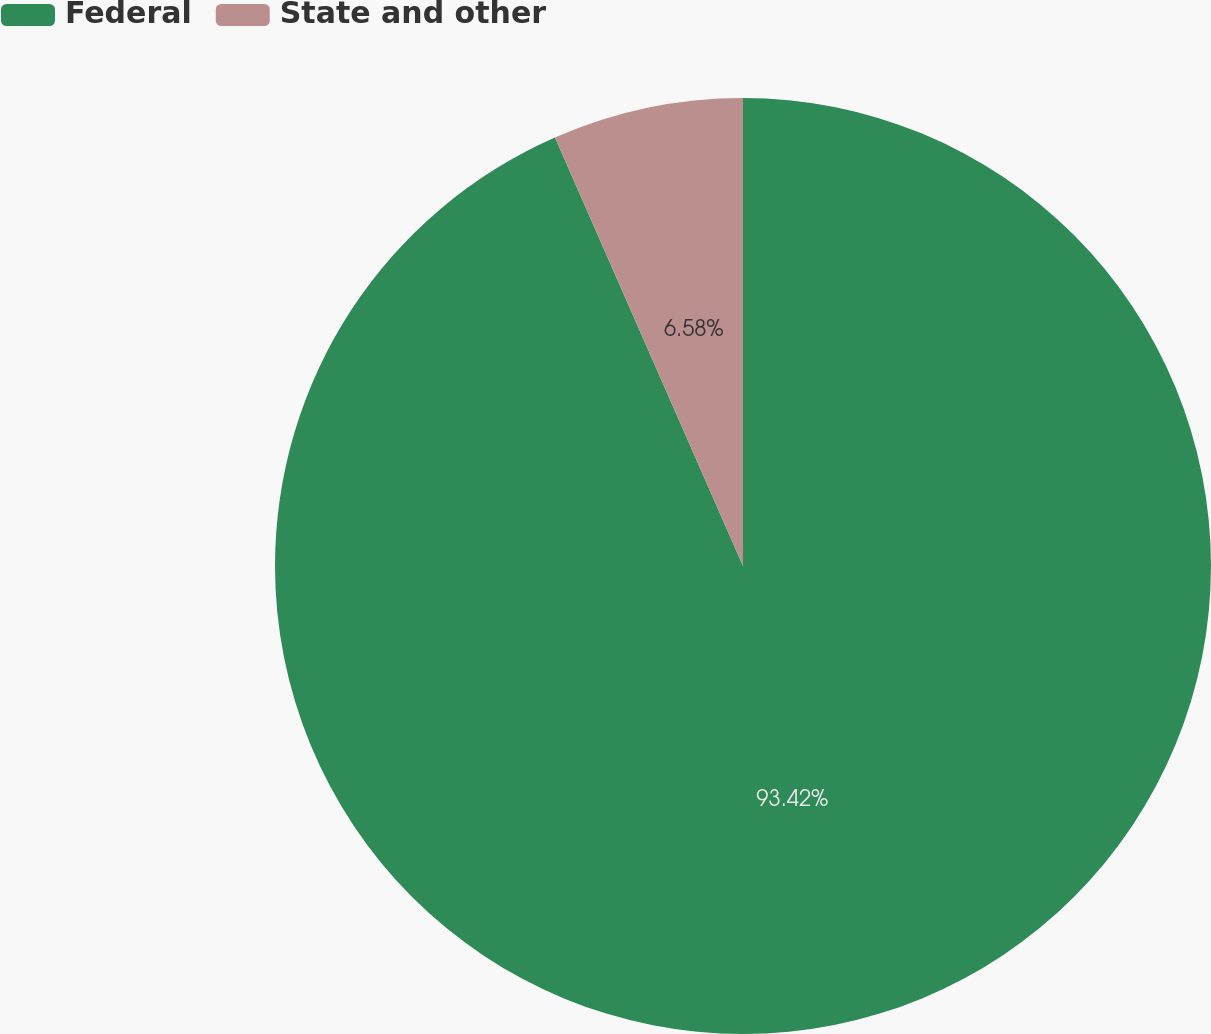Convert chart. <chart><loc_0><loc_0><loc_500><loc_500><pie_chart><fcel>Federal<fcel>State and other<nl><fcel>93.42%<fcel>6.58%<nl></chart> 